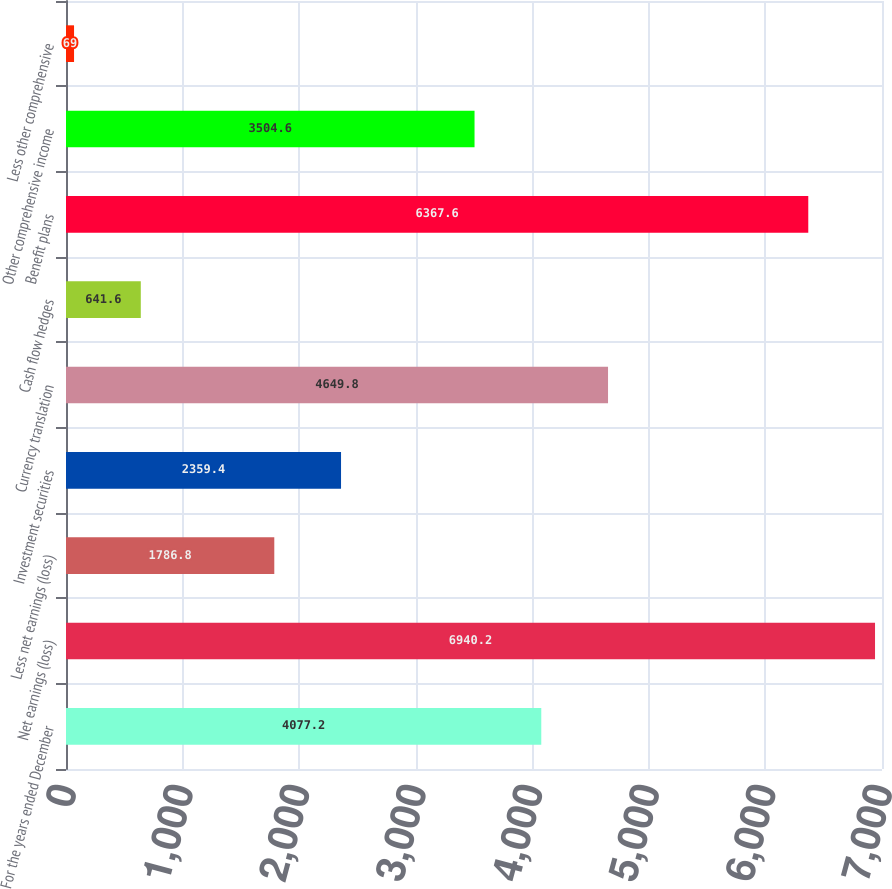Convert chart. <chart><loc_0><loc_0><loc_500><loc_500><bar_chart><fcel>For the years ended December<fcel>Net earnings (loss)<fcel>Less net earnings (loss)<fcel>Investment securities<fcel>Currency translation<fcel>Cash flow hedges<fcel>Benefit plans<fcel>Other comprehensive income<fcel>Less other comprehensive<nl><fcel>4077.2<fcel>6940.2<fcel>1786.8<fcel>2359.4<fcel>4649.8<fcel>641.6<fcel>6367.6<fcel>3504.6<fcel>69<nl></chart> 